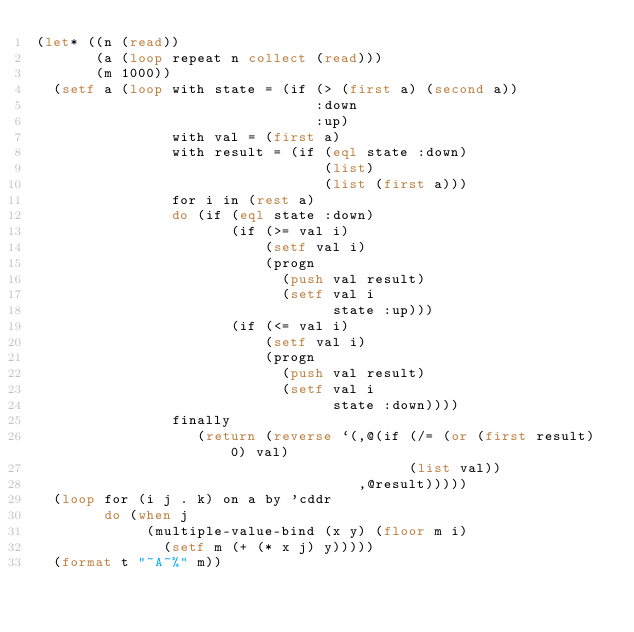<code> <loc_0><loc_0><loc_500><loc_500><_Lisp_>(let* ((n (read))
       (a (loop repeat n collect (read)))
       (m 1000))
  (setf a (loop with state = (if (> (first a) (second a))
                                 :down
                                 :up)
                with val = (first a)
                with result = (if (eql state :down)
                                  (list)
                                  (list (first a)))
                for i in (rest a)
                do (if (eql state :down)
                       (if (>= val i)
                           (setf val i)
                           (progn
                             (push val result)
                             (setf val i
                                   state :up)))
                       (if (<= val i)
                           (setf val i)
                           (progn
                             (push val result)
                             (setf val i
                                   state :down))))
                finally
                   (return (reverse `(,@(if (/= (or (first result) 0) val)
                                            (list val))
                                      ,@result)))))
  (loop for (i j . k) on a by 'cddr
        do (when j
             (multiple-value-bind (x y) (floor m i)
               (setf m (+ (* x j) y)))))
  (format t "~A~%" m))</code> 